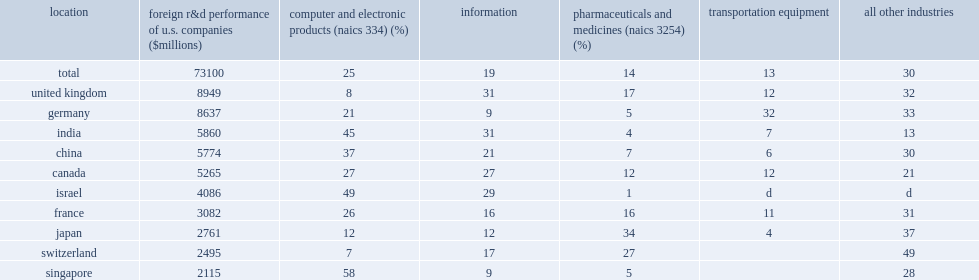How many percentage points did the computer and electronic products manufacturing industries account of the foreign r&d performance of u.s. companies in 2013? 25.0. How many percentage points did the computer and electronic products manufacturing industries account of the foreign r&d performance of u.s. companies in singapore? 58.0. How many percentage points did the computer and electronic products manufacturing industries account of the foreign r&d performance of u.s. companies in israel? 49.0. How many percentage points did the computer and electronic products manufacturing industries account of the foreign r&d performance of u.s. companies in india? 45.0. How many percentage points did the computer and electronic products manufacturing industries account of the foreign r&d performance of u.s. companies in china? 37.0. How many percent on average of the foreign r&d of the information sector (naics 51)? 19.0. How many percent of the foreign r&d of the information sector (naics 51) in the united kingdom? 31.0. How many percent of the foreign r&d of the information sector (naics 51) in india? 31.0. How many percent of the foreign r&d of the information sector (naics 51) in israel? 29.0. How many percent of the foreign r&d of the information sector (naics 51) in canada? 27.0. 